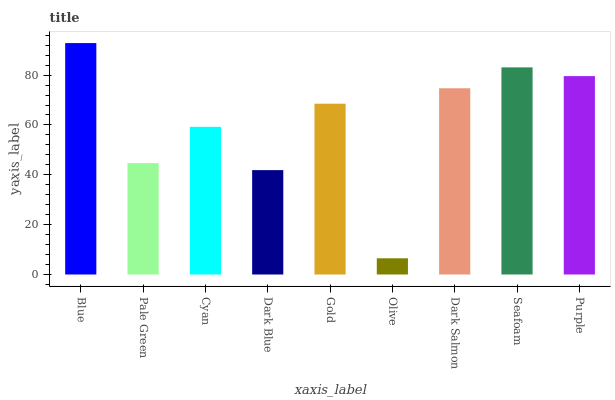Is Olive the minimum?
Answer yes or no. Yes. Is Blue the maximum?
Answer yes or no. Yes. Is Pale Green the minimum?
Answer yes or no. No. Is Pale Green the maximum?
Answer yes or no. No. Is Blue greater than Pale Green?
Answer yes or no. Yes. Is Pale Green less than Blue?
Answer yes or no. Yes. Is Pale Green greater than Blue?
Answer yes or no. No. Is Blue less than Pale Green?
Answer yes or no. No. Is Gold the high median?
Answer yes or no. Yes. Is Gold the low median?
Answer yes or no. Yes. Is Purple the high median?
Answer yes or no. No. Is Dark Salmon the low median?
Answer yes or no. No. 